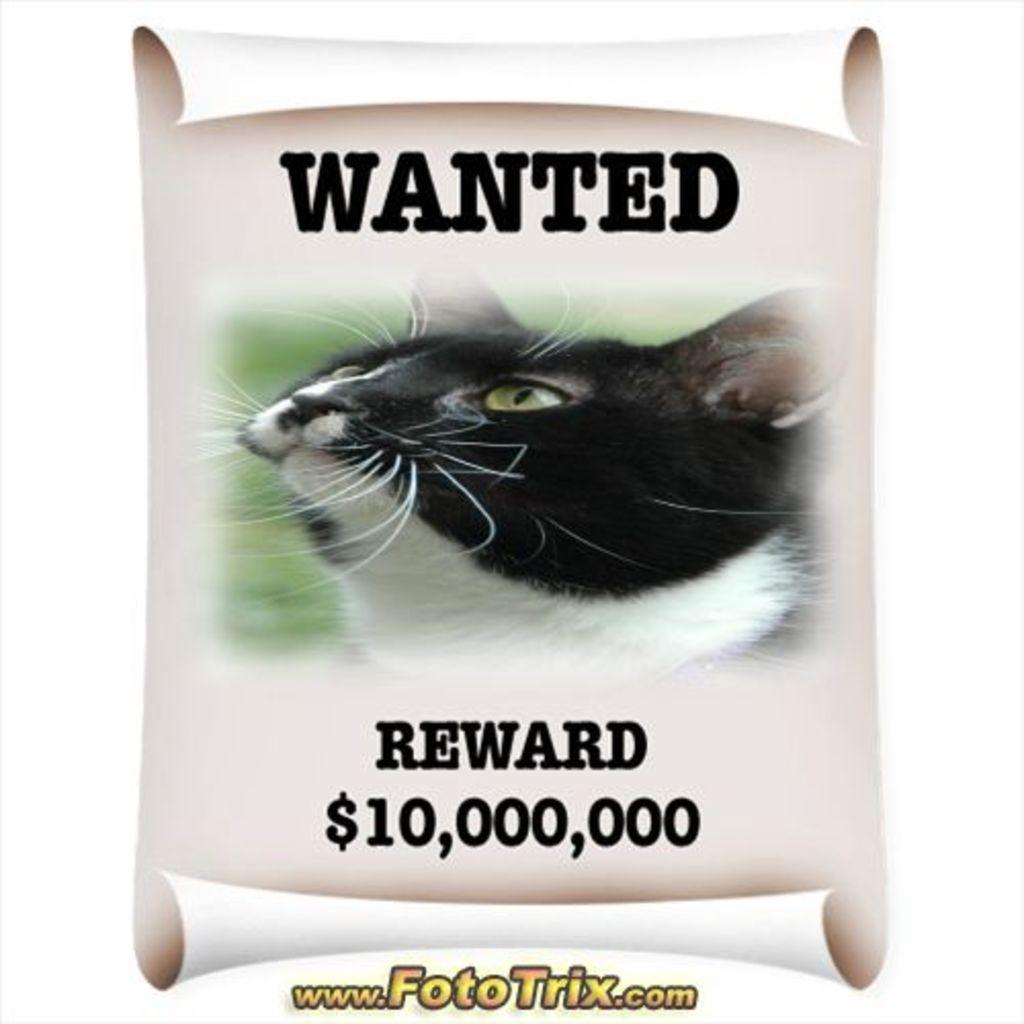In one or two sentences, can you explain what this image depicts? In this image there is a poster, on that poster there is a cat and some text, at the bottom there is text. 